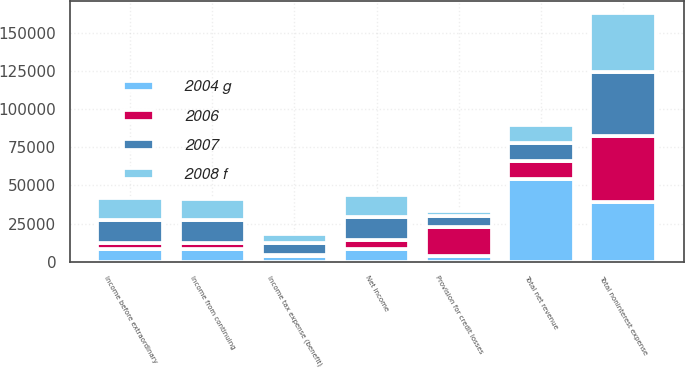Convert chart. <chart><loc_0><loc_0><loc_500><loc_500><stacked_bar_chart><ecel><fcel>Total net revenue<fcel>Provision for credit losses<fcel>Total noninterest expense<fcel>Income from continuing<fcel>Income tax expense (benefit)<fcel>Income before extraordinary<fcel>Net income<nl><fcel>2006<fcel>11839<fcel>19445<fcel>43500<fcel>3699<fcel>926<fcel>3699<fcel>5605<nl><fcel>2007<fcel>11839<fcel>6864<fcel>41703<fcel>15365<fcel>7440<fcel>15365<fcel>15365<nl><fcel>2008 f<fcel>11839<fcel>3270<fcel>38843<fcel>13649<fcel>6237<fcel>14444<fcel>14444<nl><fcel>2004 g<fcel>54248<fcel>3483<fcel>38926<fcel>8254<fcel>3585<fcel>8483<fcel>8483<nl></chart> 